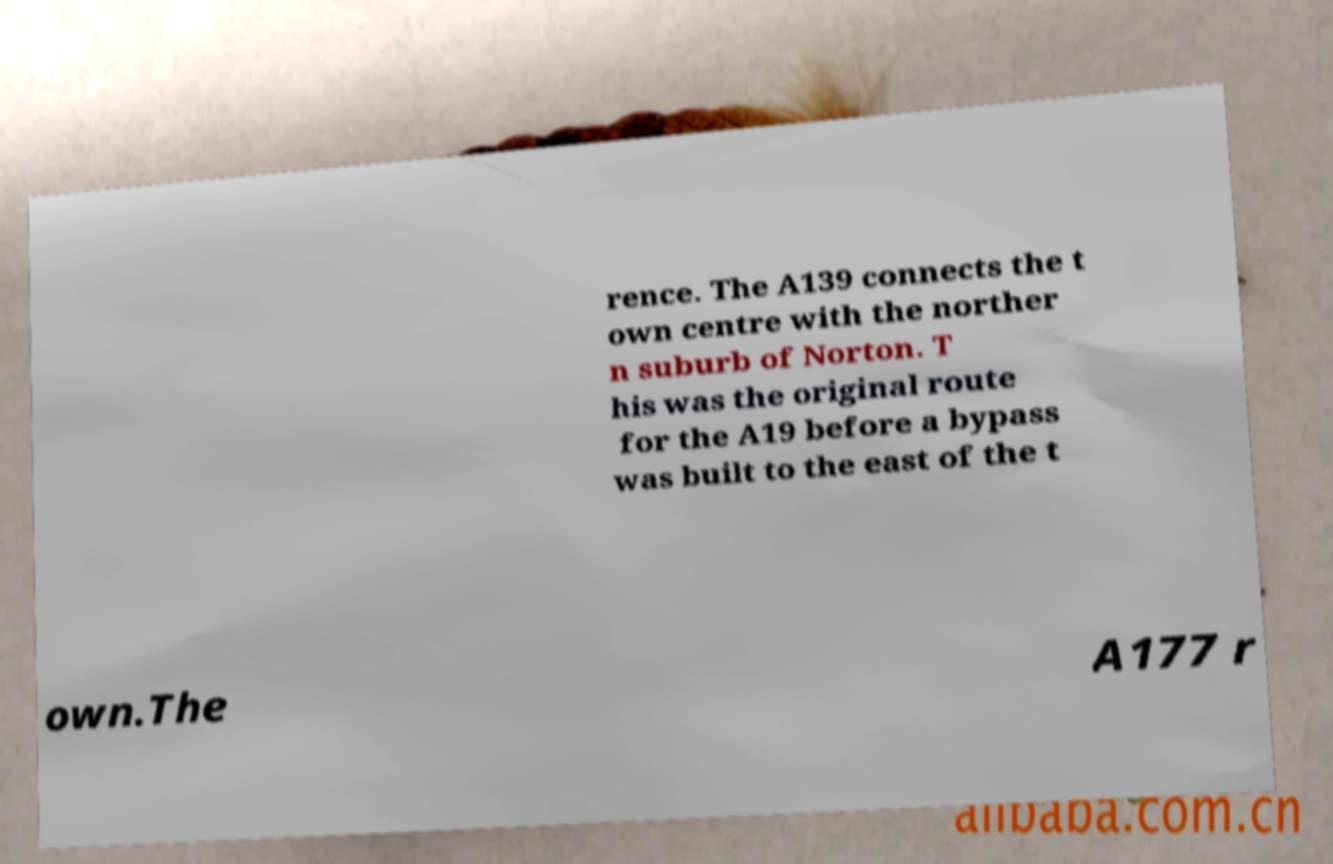Please identify and transcribe the text found in this image. rence. The A139 connects the t own centre with the norther n suburb of Norton. T his was the original route for the A19 before a bypass was built to the east of the t own.The A177 r 